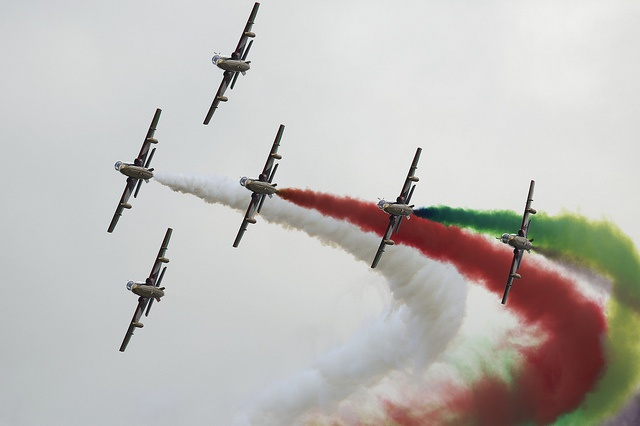Describe the objects in this image and their specific colors. I can see airplane in lightgray, black, gray, and darkgray tones, airplane in lightgray, black, gray, and darkgray tones, airplane in lightgray, black, gray, and darkgray tones, airplane in lightgray, black, gray, and darkgray tones, and airplane in lightgray, black, gray, darkgray, and maroon tones in this image. 